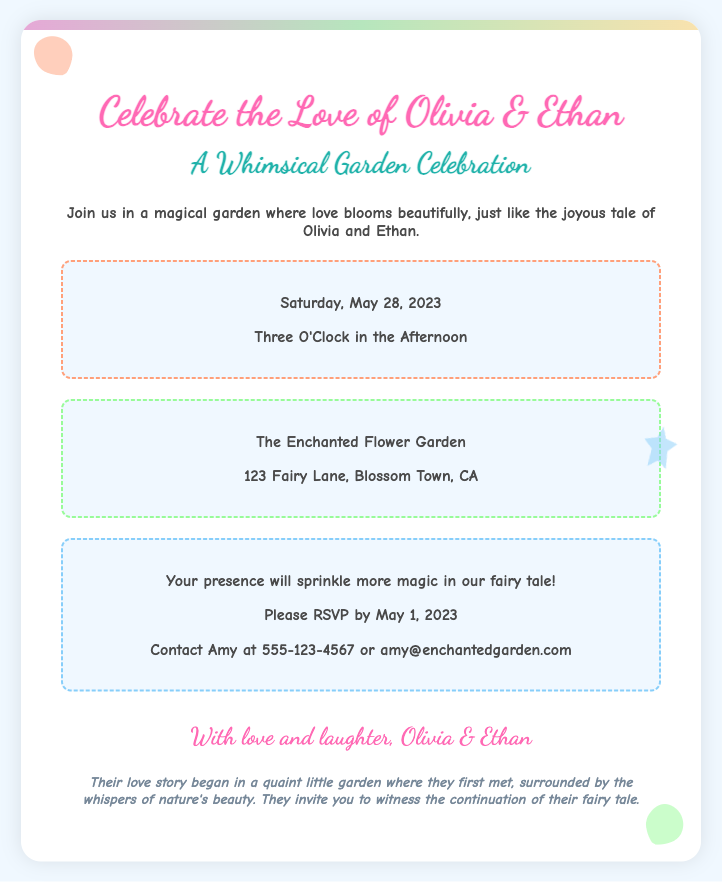What are the names of the bride and groom? The names of the bride and groom are stated as Olivia and Ethan in the title of the invitation.
Answer: Olivia & Ethan What is the date of the wedding? The date is explicitly mentioned in the document under the date-time section.
Answer: May 28, 2023 At what time will the wedding take place? The time is specified in the date-time section of the invitation.
Answer: Three O'Clock in the Afternoon Where is the wedding ceremony being held? The location is provided in the location section of the invitation, giving the venue name and address.
Answer: The Enchanted Flower Garden What is the RSVP deadline? The RSVP deadline is given in the RSVP section of the invitation.
Answer: May 1, 2023 What is the contact information for RSVPs? The contact for RSVPs is provided in the RSVP section, including a name, phone number, and email.
Answer: Amy at 555-123-4567 or amy@enchantedgarden.com What type of theme is the wedding invitation designed around? The invitation describes its theme in the subtitle and main text, indicating its whimsical nature.
Answer: Whimsical Garden What is mentioned about the couple's love story? The love story section briefly narrates the beginning of their relationship and its connection to the wedding theme.
Answer: They first met in a quaint little garden What imagery is used in the invitation? Descriptions of flowers and a butterfly in the design notes hint at the playful elements reflecting the wedding's garden theme.
Answer: Child-like illustrations and playful fonts 